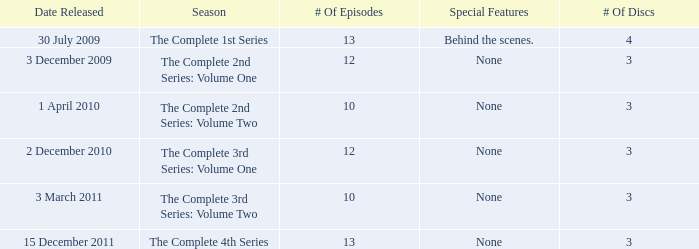What day was the complete 2nd series: volume one released? 3 December 2009. 